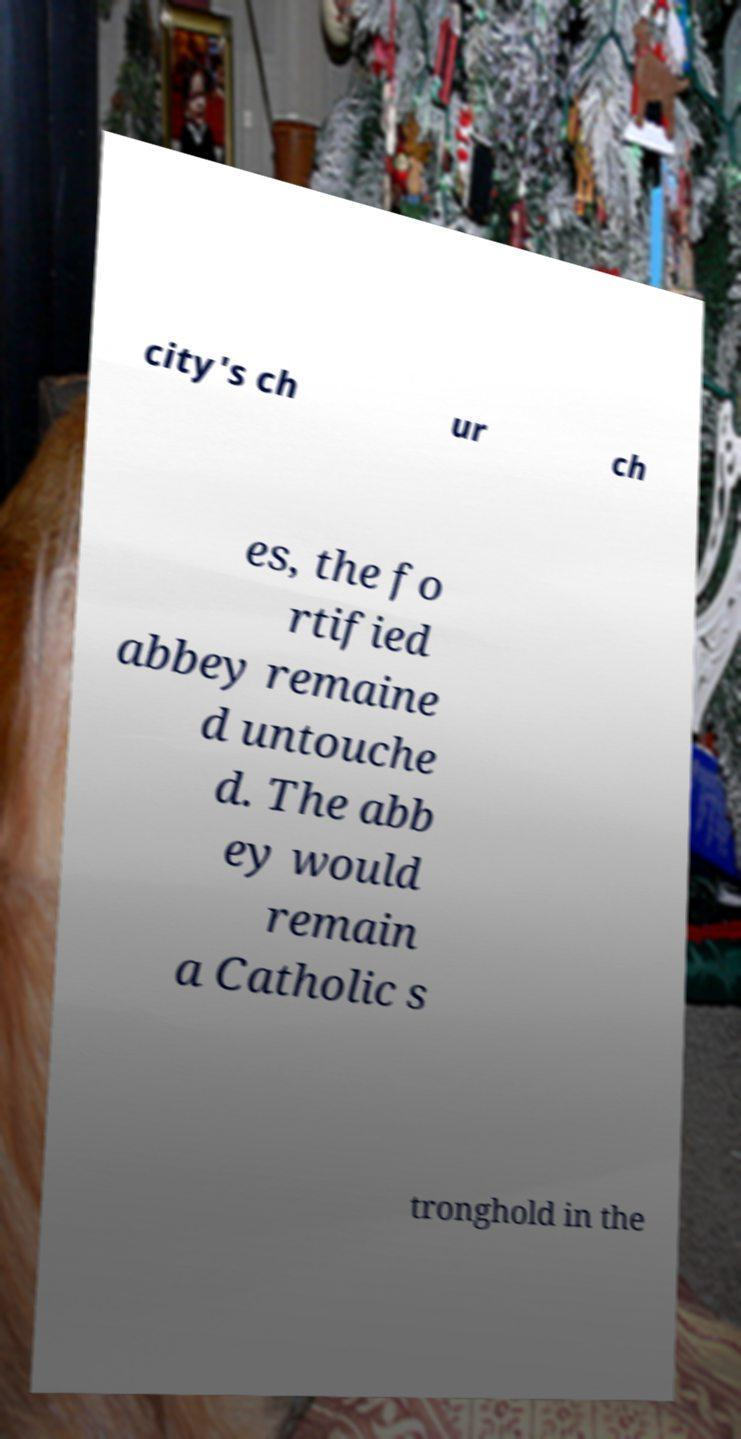Can you accurately transcribe the text from the provided image for me? city's ch ur ch es, the fo rtified abbey remaine d untouche d. The abb ey would remain a Catholic s tronghold in the 